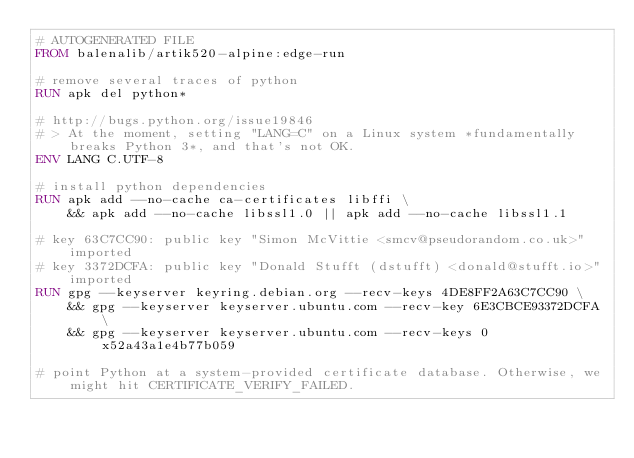<code> <loc_0><loc_0><loc_500><loc_500><_Dockerfile_># AUTOGENERATED FILE
FROM balenalib/artik520-alpine:edge-run

# remove several traces of python
RUN apk del python*

# http://bugs.python.org/issue19846
# > At the moment, setting "LANG=C" on a Linux system *fundamentally breaks Python 3*, and that's not OK.
ENV LANG C.UTF-8

# install python dependencies
RUN apk add --no-cache ca-certificates libffi \
	&& apk add --no-cache libssl1.0 || apk add --no-cache libssl1.1

# key 63C7CC90: public key "Simon McVittie <smcv@pseudorandom.co.uk>" imported
# key 3372DCFA: public key "Donald Stufft (dstufft) <donald@stufft.io>" imported
RUN gpg --keyserver keyring.debian.org --recv-keys 4DE8FF2A63C7CC90 \
	&& gpg --keyserver keyserver.ubuntu.com --recv-key 6E3CBCE93372DCFA \
	&& gpg --keyserver keyserver.ubuntu.com --recv-keys 0x52a43a1e4b77b059

# point Python at a system-provided certificate database. Otherwise, we might hit CERTIFICATE_VERIFY_FAILED.</code> 